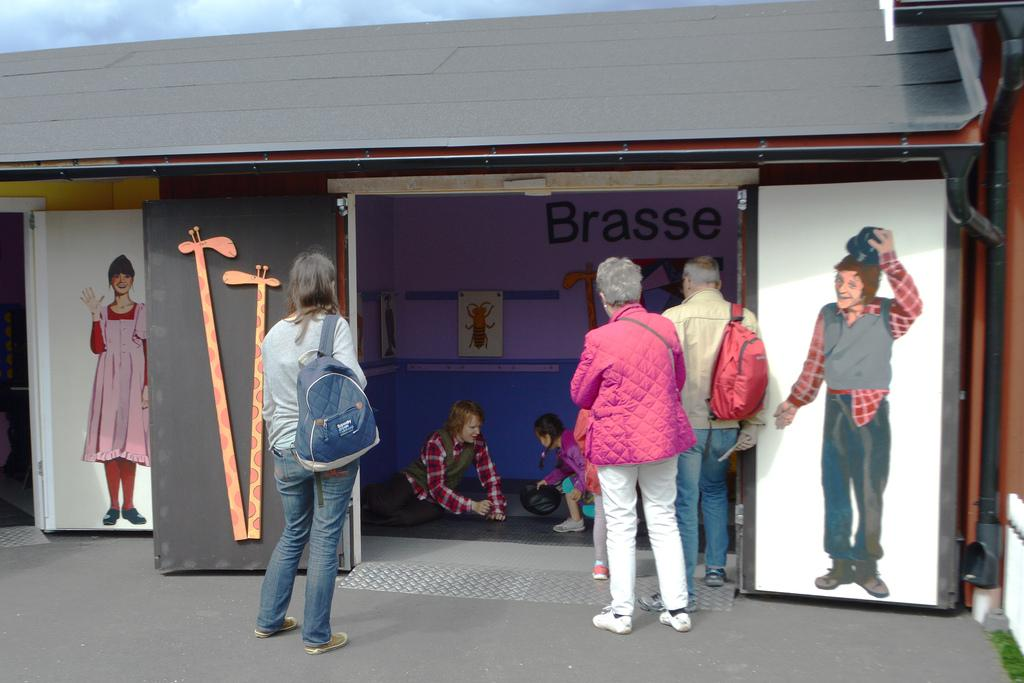Who is present in the image? There are people in the image. What are the people doing? The people are watching activities. Where are the activities taking place? The activities are taking place in a stall or shed. What can be seen on the sides of the image? There are pictures on the left side and the right side of the image. Can you see a snake slithering in the image? There is no snake present in the image. Is there an animal flying in the image? There is no animal flying in the image. 